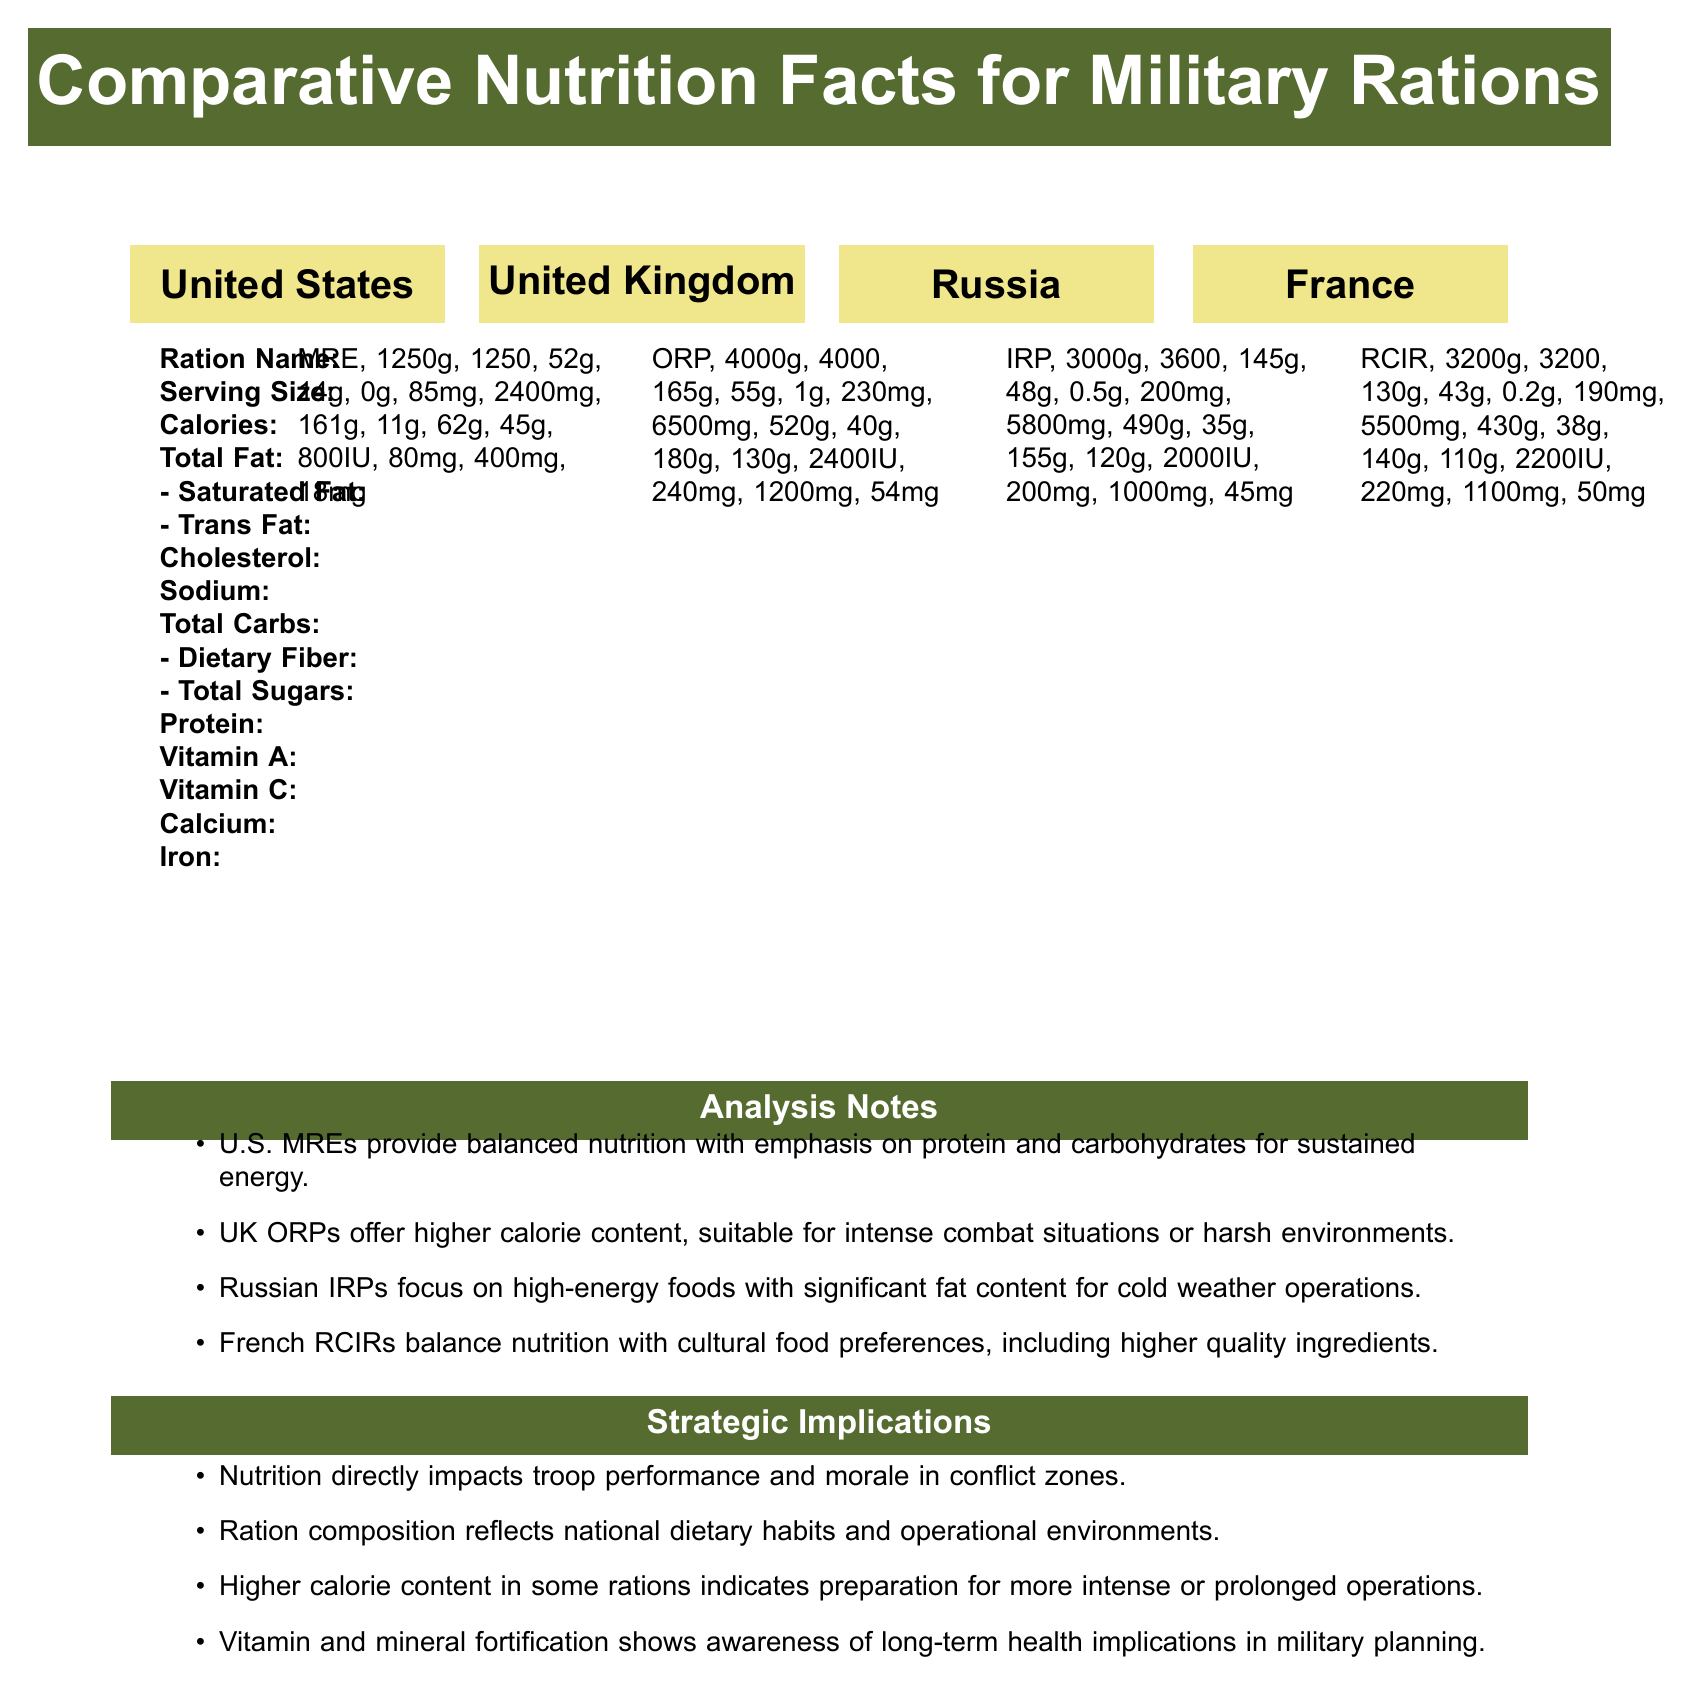what is the serving size of the U.S. MRE? According to the document, the serving size for the U.S. MRE is specified as "1 meal pack (about 1250g)".
Answer: 1 meal pack (about 1250g) how many calories are in the French RCIR ration? The document states that the French RCIR contains 3200 calories as shown in the listed details under France.
Answer: 3200 which country's ration has the highest amount of sodium? The UK's ORP contains 6500mg of sodium, which is the highest among the listed military rations.
Answer: United Kingdom what is the total fat content in the Russian IRP ration? The document indicates that the Russian IRP has a total fat content of 145g.
Answer: 145g how much protein does the UK ORP provide? According to the document, the UK ORP provides 130g of protein.
Answer: 130g which ration provides the highest amount of Vitamin C? A. U.S. MRE B. UK ORP C. Russian IRP D. French RCIR The UK ORP provides 240mg of Vitamin C, which is the highest compared to the other rations listed.
Answer: B. UK ORP which ration has the lowest cholesterol content? 1. U.S. MRE 2. UK ORP 3. Russian IRP 4. French RCIR The U.S. MRE contains 85mg of cholesterol, which is the lowest among the rations listed.
Answer: 1. U.S. MRE do all rations provide trans fat? According to the document, not all rations contain trans fat. The U.S. MRE and the Russian IRP have 0g and 0.5g trans fat respectively, while the UK ORP has 1g and the French RCIR has 0.2g.
Answer: No summarize the nutritional focus of the different military rations provided in the document The document details the nutrition facts for military rations from the U.S., UK, Russia, and France, highlighting their specific nutritional focus and operational suitability based on the environment and cultural factors.
Answer: Each country's military ration is designed to meet operational needs and reflect national dietary preferences. The U.S. MREs emphasize protein and carbohydrates for sustained energy. The UK ORPs are high-calorie, suitable for intense combat situations. Russian IRPs include high-energy foods with significant fat content for cold weather operations. French RCIRs balance nutrition with cultural preferences and include higher quality ingredients. how does the caloric content of the U.S. MRE compare to the Russian IRP? The comparison shows that the Russian IRP provides more than double the caloric content of the U.S. MRE.
Answer: The U.S. MRE has 1250 calories, while the Russian IRP has 3600 calories, making the Russian IRP significantly higher in caloric content. what is the main ingredient contributing to the high energy supply in Russian IRPs? The document mentions that Russian IRPs focus on high-energy foods with significant fat content, indicating that fat is a major contributor to the high energy supply.
Answer: Fat what are the strategic implications mentioned in the document? The document lists several strategic implications, such as the direct impact of nutrition on troop performance, reflection of national dietary habits, preparation for intense or prolonged operations, and awareness of long-term health through vitamin and mineral fortification.
Answer: Nutrition impacts troop performance and morale, reflects dietary habits and operational environments, prepares for intense operations, and fortification shows health awareness. what is the price of each country's ration pack? The document does not provide any information about the price of the ration packs, making it impossible to determine their cost.
Answer: Cannot be determined 